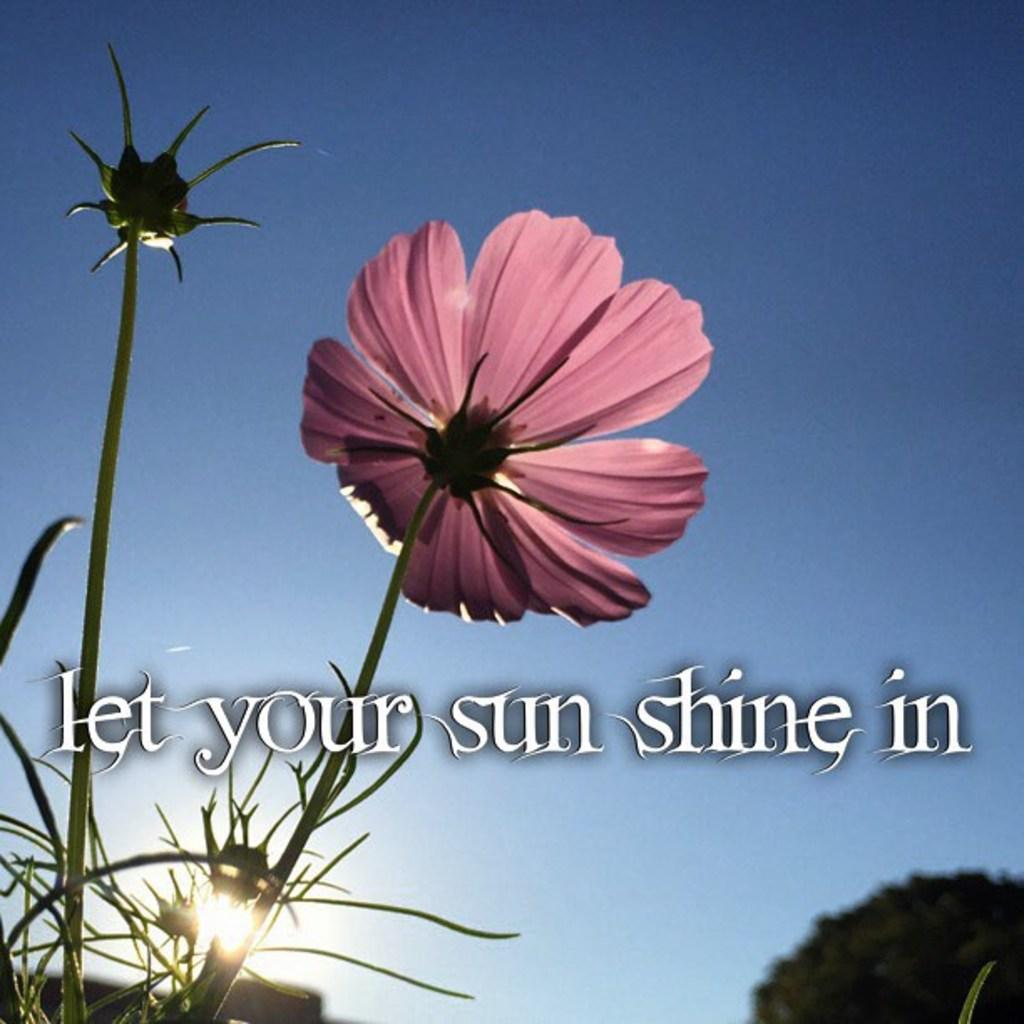What color is the flower in the image? The flower in the image is pink. What can be seen in the background of the image? There are trees in the background of the image, and they are green. What color is the sky in the image? The sky is blue in the image. Is there any text or writing present in the image? Yes, there is text or writing present in the image. What type of cream is being used to paint the gate in the image? There is no gate or painting activity present in the image. 